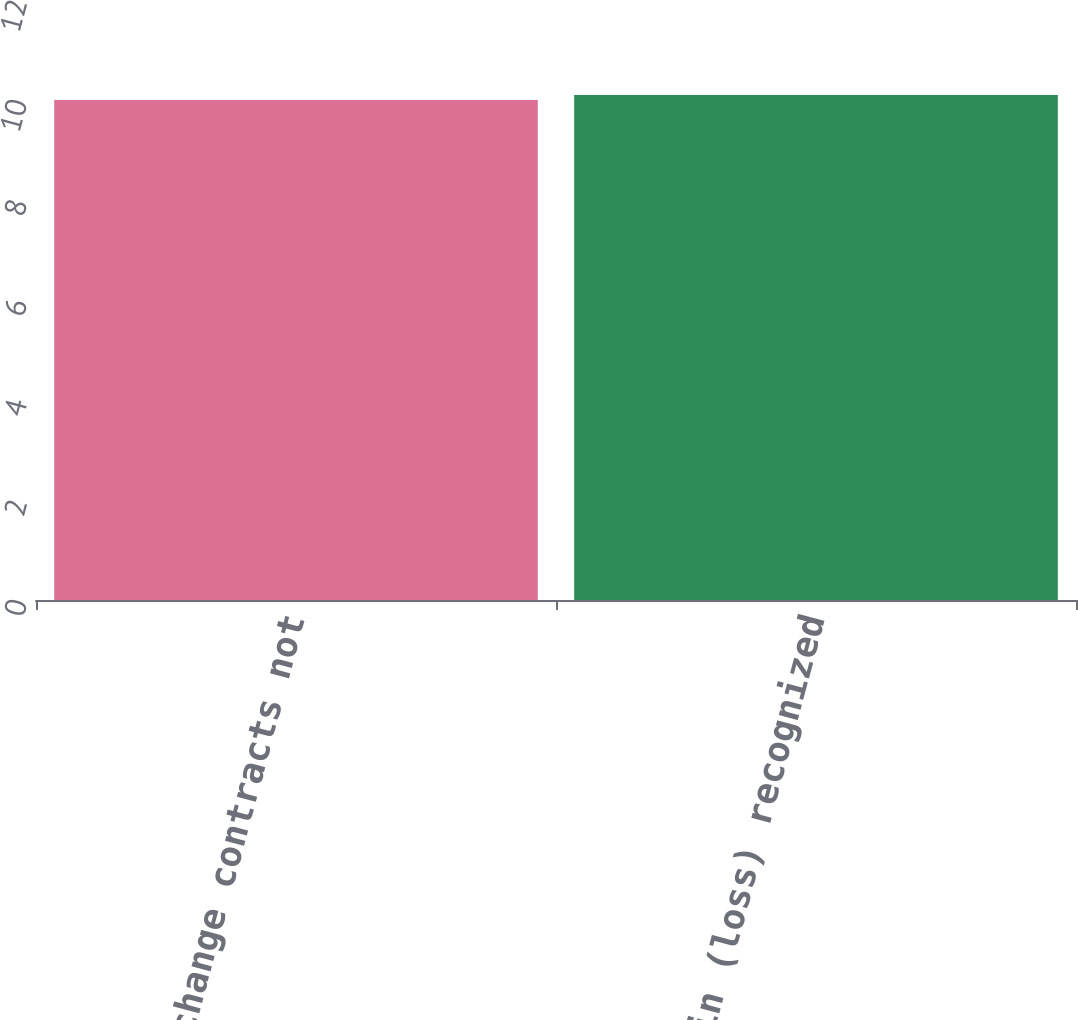<chart> <loc_0><loc_0><loc_500><loc_500><bar_chart><fcel>Foreign exchange contracts not<fcel>Total gain (loss) recognized<nl><fcel>10<fcel>10.1<nl></chart> 